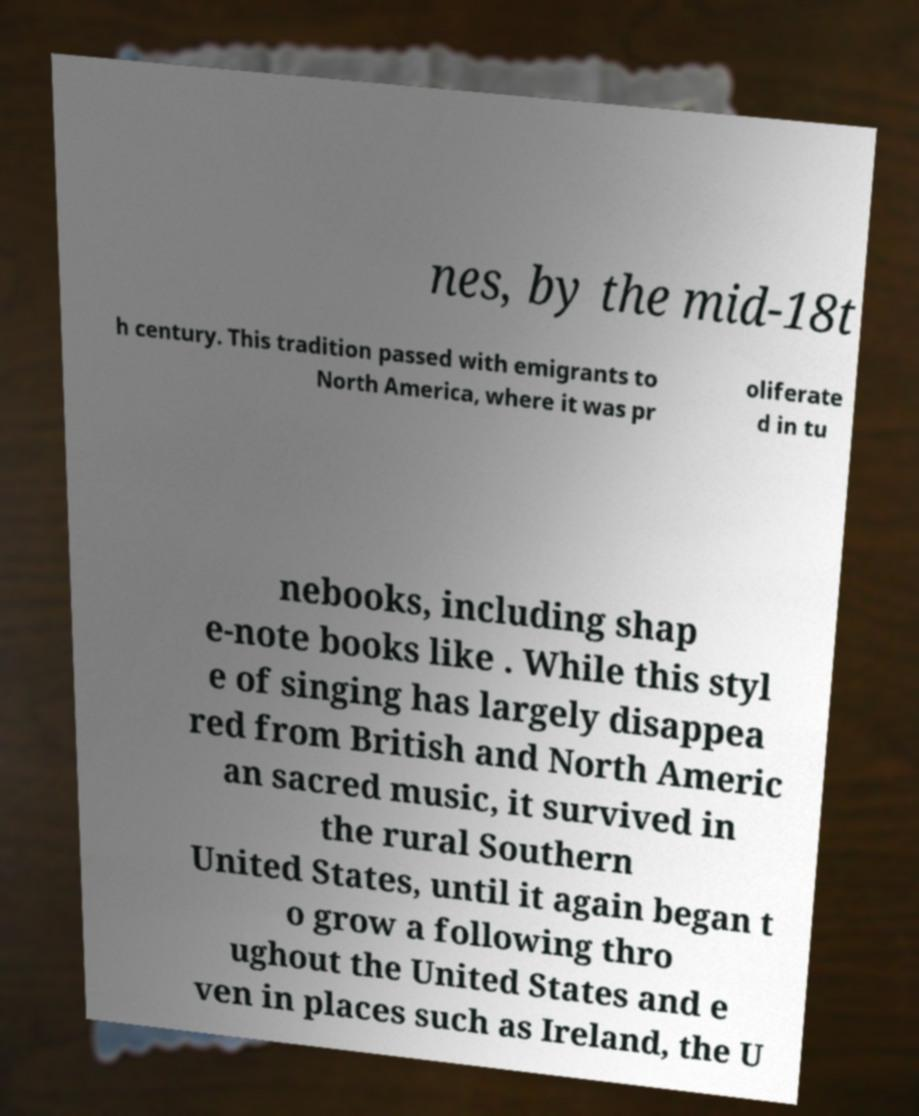Please identify and transcribe the text found in this image. nes, by the mid-18t h century. This tradition passed with emigrants to North America, where it was pr oliferate d in tu nebooks, including shap e-note books like . While this styl e of singing has largely disappea red from British and North Americ an sacred music, it survived in the rural Southern United States, until it again began t o grow a following thro ughout the United States and e ven in places such as Ireland, the U 